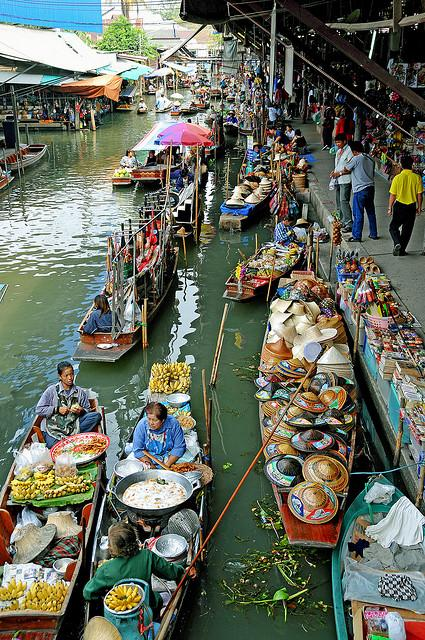What are on some of the boats?

Choices:
A) cows
B) cats
C) bananas
D) surfboards bananas 